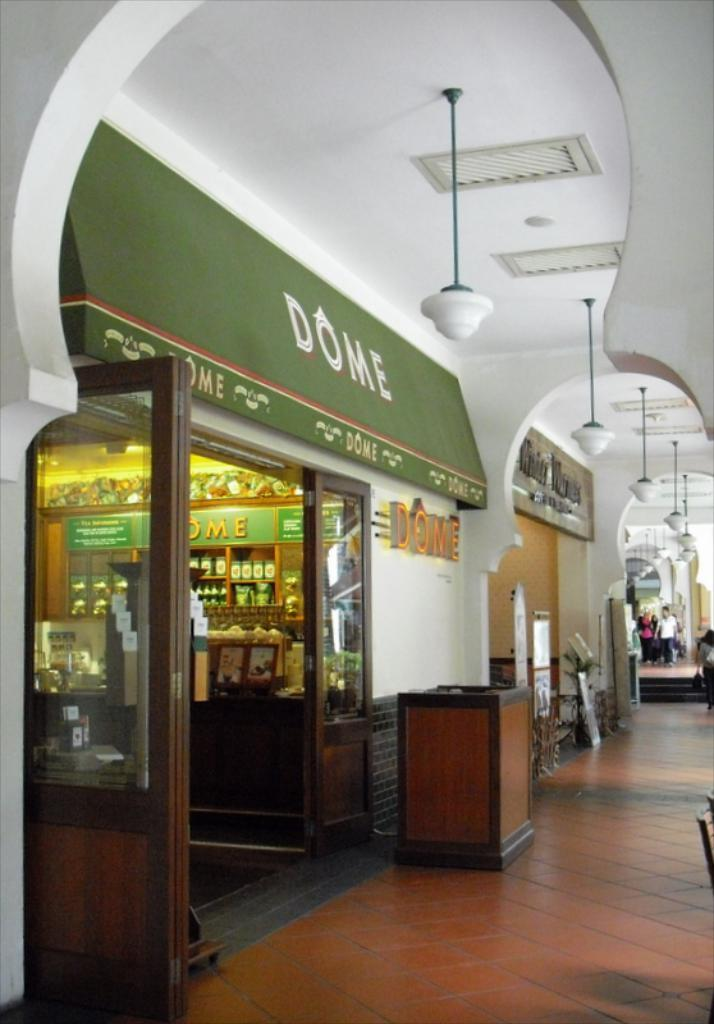<image>
Share a concise interpretation of the image provided. The awning for Dome is green and has a red strip on it. 